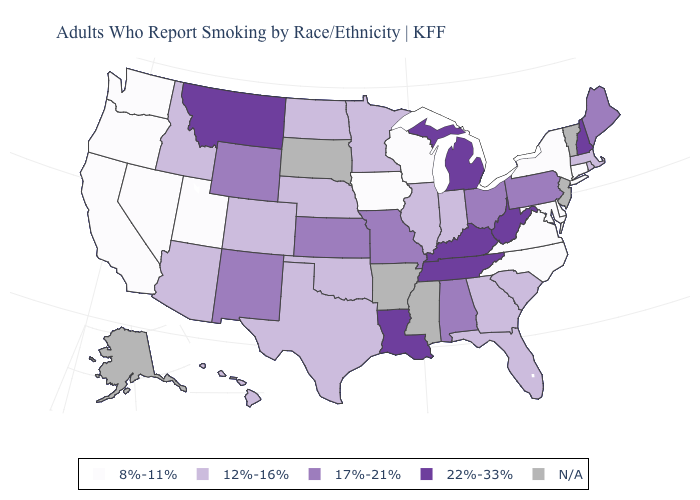What is the value of Pennsylvania?
Answer briefly. 17%-21%. Name the states that have a value in the range 12%-16%?
Write a very short answer. Arizona, Colorado, Florida, Georgia, Hawaii, Idaho, Illinois, Indiana, Massachusetts, Minnesota, Nebraska, North Dakota, Oklahoma, Rhode Island, South Carolina, Texas. Does Tennessee have the highest value in the USA?
Quick response, please. Yes. Does Louisiana have the highest value in the USA?
Keep it brief. Yes. Does Indiana have the lowest value in the USA?
Give a very brief answer. No. How many symbols are there in the legend?
Be succinct. 5. Name the states that have a value in the range N/A?
Be succinct. Alaska, Arkansas, Mississippi, New Jersey, South Dakota, Vermont. Does Delaware have the lowest value in the USA?
Answer briefly. Yes. Which states hav the highest value in the West?
Be succinct. Montana. Name the states that have a value in the range 17%-21%?
Write a very short answer. Alabama, Kansas, Maine, Missouri, New Mexico, Ohio, Pennsylvania, Wyoming. 